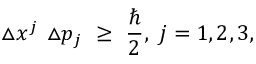Convert formula to latex. <formula><loc_0><loc_0><loc_500><loc_500>\triangle x ^ { j } \ \triangle p _ { j } \ \geq \ \frac { } { 2 } , \ j = 1 , 2 , 3 ,</formula> 